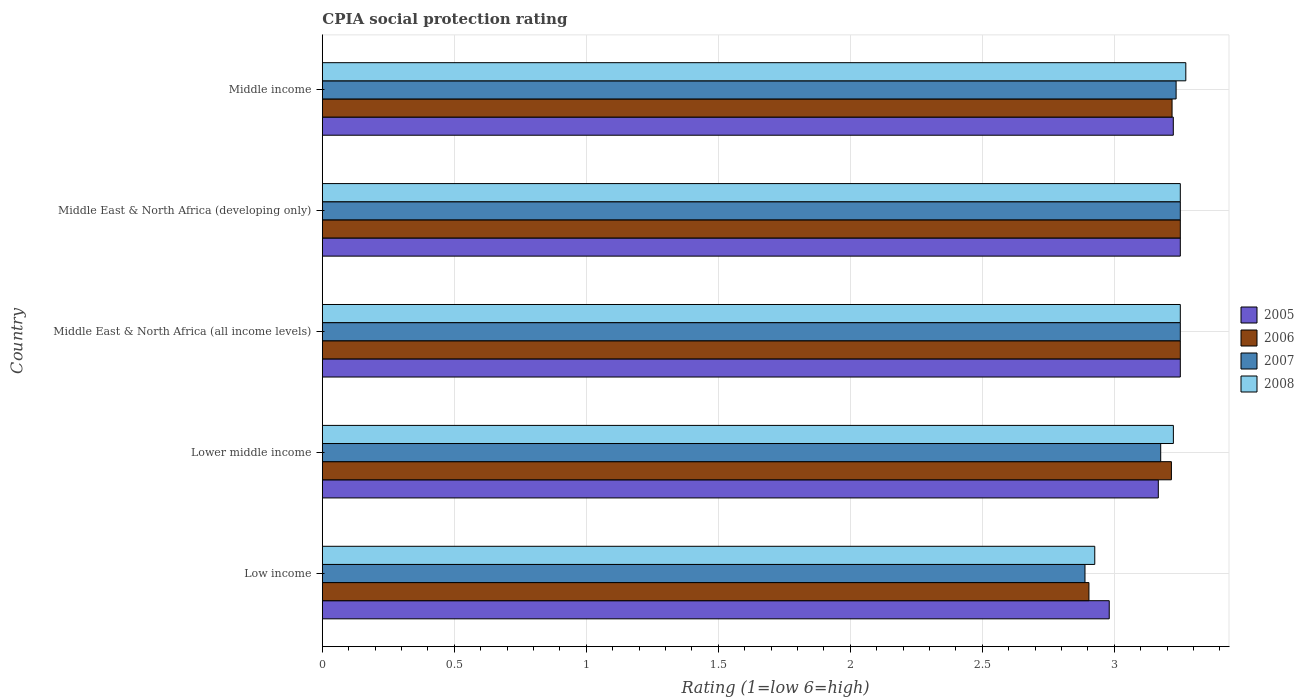How many groups of bars are there?
Your answer should be very brief. 5. Are the number of bars per tick equal to the number of legend labels?
Offer a terse response. Yes. What is the label of the 3rd group of bars from the top?
Your response must be concise. Middle East & North Africa (all income levels). In how many cases, is the number of bars for a given country not equal to the number of legend labels?
Provide a succinct answer. 0. What is the CPIA rating in 2008 in Middle income?
Provide a succinct answer. 3.27. Across all countries, what is the maximum CPIA rating in 2008?
Make the answer very short. 3.27. Across all countries, what is the minimum CPIA rating in 2008?
Your response must be concise. 2.93. In which country was the CPIA rating in 2006 maximum?
Your answer should be very brief. Middle East & North Africa (all income levels). In which country was the CPIA rating in 2006 minimum?
Ensure brevity in your answer.  Low income. What is the total CPIA rating in 2007 in the graph?
Your response must be concise. 15.8. What is the difference between the CPIA rating in 2008 in Low income and that in Middle East & North Africa (all income levels)?
Provide a succinct answer. -0.32. What is the difference between the CPIA rating in 2008 in Middle income and the CPIA rating in 2006 in Middle East & North Africa (developing only)?
Keep it short and to the point. 0.02. What is the average CPIA rating in 2005 per country?
Your response must be concise. 3.17. What is the ratio of the CPIA rating in 2008 in Low income to that in Lower middle income?
Your answer should be compact. 0.91. Is the difference between the CPIA rating in 2006 in Lower middle income and Middle income greater than the difference between the CPIA rating in 2007 in Lower middle income and Middle income?
Offer a very short reply. Yes. What is the difference between the highest and the second highest CPIA rating in 2007?
Keep it short and to the point. 0. What is the difference between the highest and the lowest CPIA rating in 2008?
Offer a terse response. 0.34. In how many countries, is the CPIA rating in 2005 greater than the average CPIA rating in 2005 taken over all countries?
Provide a short and direct response. 3. Is it the case that in every country, the sum of the CPIA rating in 2006 and CPIA rating in 2008 is greater than the sum of CPIA rating in 2007 and CPIA rating in 2005?
Your answer should be compact. No. What does the 4th bar from the top in Middle East & North Africa (all income levels) represents?
Offer a terse response. 2005. Are all the bars in the graph horizontal?
Ensure brevity in your answer.  Yes. How many countries are there in the graph?
Your answer should be very brief. 5. What is the difference between two consecutive major ticks on the X-axis?
Ensure brevity in your answer.  0.5. Does the graph contain any zero values?
Give a very brief answer. No. Does the graph contain grids?
Ensure brevity in your answer.  Yes. Where does the legend appear in the graph?
Your response must be concise. Center right. How many legend labels are there?
Keep it short and to the point. 4. What is the title of the graph?
Your answer should be compact. CPIA social protection rating. What is the label or title of the X-axis?
Provide a short and direct response. Rating (1=low 6=high). What is the label or title of the Y-axis?
Offer a terse response. Country. What is the Rating (1=low 6=high) of 2005 in Low income?
Make the answer very short. 2.98. What is the Rating (1=low 6=high) in 2006 in Low income?
Make the answer very short. 2.9. What is the Rating (1=low 6=high) in 2007 in Low income?
Your answer should be very brief. 2.89. What is the Rating (1=low 6=high) of 2008 in Low income?
Offer a very short reply. 2.93. What is the Rating (1=low 6=high) of 2005 in Lower middle income?
Your response must be concise. 3.17. What is the Rating (1=low 6=high) in 2006 in Lower middle income?
Provide a succinct answer. 3.22. What is the Rating (1=low 6=high) in 2007 in Lower middle income?
Offer a very short reply. 3.18. What is the Rating (1=low 6=high) in 2008 in Lower middle income?
Give a very brief answer. 3.22. What is the Rating (1=low 6=high) in 2005 in Middle East & North Africa (all income levels)?
Your answer should be compact. 3.25. What is the Rating (1=low 6=high) of 2007 in Middle East & North Africa (all income levels)?
Offer a very short reply. 3.25. What is the Rating (1=low 6=high) of 2007 in Middle East & North Africa (developing only)?
Your answer should be very brief. 3.25. What is the Rating (1=low 6=high) in 2008 in Middle East & North Africa (developing only)?
Give a very brief answer. 3.25. What is the Rating (1=low 6=high) in 2005 in Middle income?
Offer a terse response. 3.22. What is the Rating (1=low 6=high) of 2006 in Middle income?
Your response must be concise. 3.22. What is the Rating (1=low 6=high) of 2007 in Middle income?
Your response must be concise. 3.23. What is the Rating (1=low 6=high) of 2008 in Middle income?
Give a very brief answer. 3.27. Across all countries, what is the maximum Rating (1=low 6=high) of 2006?
Provide a short and direct response. 3.25. Across all countries, what is the maximum Rating (1=low 6=high) of 2007?
Provide a short and direct response. 3.25. Across all countries, what is the maximum Rating (1=low 6=high) in 2008?
Your response must be concise. 3.27. Across all countries, what is the minimum Rating (1=low 6=high) in 2005?
Your answer should be compact. 2.98. Across all countries, what is the minimum Rating (1=low 6=high) of 2006?
Your answer should be compact. 2.9. Across all countries, what is the minimum Rating (1=low 6=high) of 2007?
Ensure brevity in your answer.  2.89. Across all countries, what is the minimum Rating (1=low 6=high) of 2008?
Keep it short and to the point. 2.93. What is the total Rating (1=low 6=high) in 2005 in the graph?
Ensure brevity in your answer.  15.87. What is the total Rating (1=low 6=high) of 2006 in the graph?
Make the answer very short. 15.84. What is the total Rating (1=low 6=high) in 2007 in the graph?
Ensure brevity in your answer.  15.8. What is the total Rating (1=low 6=high) in 2008 in the graph?
Keep it short and to the point. 15.92. What is the difference between the Rating (1=low 6=high) of 2005 in Low income and that in Lower middle income?
Your answer should be very brief. -0.19. What is the difference between the Rating (1=low 6=high) in 2006 in Low income and that in Lower middle income?
Give a very brief answer. -0.31. What is the difference between the Rating (1=low 6=high) in 2007 in Low income and that in Lower middle income?
Provide a succinct answer. -0.29. What is the difference between the Rating (1=low 6=high) in 2008 in Low income and that in Lower middle income?
Your answer should be compact. -0.3. What is the difference between the Rating (1=low 6=high) of 2005 in Low income and that in Middle East & North Africa (all income levels)?
Your answer should be very brief. -0.27. What is the difference between the Rating (1=low 6=high) in 2006 in Low income and that in Middle East & North Africa (all income levels)?
Provide a short and direct response. -0.35. What is the difference between the Rating (1=low 6=high) in 2007 in Low income and that in Middle East & North Africa (all income levels)?
Offer a very short reply. -0.36. What is the difference between the Rating (1=low 6=high) of 2008 in Low income and that in Middle East & North Africa (all income levels)?
Offer a terse response. -0.32. What is the difference between the Rating (1=low 6=high) in 2005 in Low income and that in Middle East & North Africa (developing only)?
Offer a very short reply. -0.27. What is the difference between the Rating (1=low 6=high) in 2006 in Low income and that in Middle East & North Africa (developing only)?
Offer a terse response. -0.35. What is the difference between the Rating (1=low 6=high) in 2007 in Low income and that in Middle East & North Africa (developing only)?
Ensure brevity in your answer.  -0.36. What is the difference between the Rating (1=low 6=high) of 2008 in Low income and that in Middle East & North Africa (developing only)?
Offer a very short reply. -0.32. What is the difference between the Rating (1=low 6=high) of 2005 in Low income and that in Middle income?
Offer a very short reply. -0.24. What is the difference between the Rating (1=low 6=high) in 2006 in Low income and that in Middle income?
Your answer should be compact. -0.31. What is the difference between the Rating (1=low 6=high) of 2007 in Low income and that in Middle income?
Provide a succinct answer. -0.35. What is the difference between the Rating (1=low 6=high) of 2008 in Low income and that in Middle income?
Offer a terse response. -0.34. What is the difference between the Rating (1=low 6=high) of 2005 in Lower middle income and that in Middle East & North Africa (all income levels)?
Give a very brief answer. -0.08. What is the difference between the Rating (1=low 6=high) of 2006 in Lower middle income and that in Middle East & North Africa (all income levels)?
Ensure brevity in your answer.  -0.03. What is the difference between the Rating (1=low 6=high) in 2007 in Lower middle income and that in Middle East & North Africa (all income levels)?
Ensure brevity in your answer.  -0.07. What is the difference between the Rating (1=low 6=high) in 2008 in Lower middle income and that in Middle East & North Africa (all income levels)?
Offer a very short reply. -0.03. What is the difference between the Rating (1=low 6=high) of 2005 in Lower middle income and that in Middle East & North Africa (developing only)?
Give a very brief answer. -0.08. What is the difference between the Rating (1=low 6=high) of 2006 in Lower middle income and that in Middle East & North Africa (developing only)?
Keep it short and to the point. -0.03. What is the difference between the Rating (1=low 6=high) in 2007 in Lower middle income and that in Middle East & North Africa (developing only)?
Provide a short and direct response. -0.07. What is the difference between the Rating (1=low 6=high) of 2008 in Lower middle income and that in Middle East & North Africa (developing only)?
Your response must be concise. -0.03. What is the difference between the Rating (1=low 6=high) of 2005 in Lower middle income and that in Middle income?
Provide a succinct answer. -0.06. What is the difference between the Rating (1=low 6=high) of 2006 in Lower middle income and that in Middle income?
Offer a terse response. -0. What is the difference between the Rating (1=low 6=high) in 2007 in Lower middle income and that in Middle income?
Provide a short and direct response. -0.06. What is the difference between the Rating (1=low 6=high) in 2008 in Lower middle income and that in Middle income?
Provide a succinct answer. -0.05. What is the difference between the Rating (1=low 6=high) of 2007 in Middle East & North Africa (all income levels) and that in Middle East & North Africa (developing only)?
Provide a short and direct response. 0. What is the difference between the Rating (1=low 6=high) of 2005 in Middle East & North Africa (all income levels) and that in Middle income?
Keep it short and to the point. 0.03. What is the difference between the Rating (1=low 6=high) in 2006 in Middle East & North Africa (all income levels) and that in Middle income?
Offer a very short reply. 0.03. What is the difference between the Rating (1=low 6=high) in 2007 in Middle East & North Africa (all income levels) and that in Middle income?
Your answer should be compact. 0.02. What is the difference between the Rating (1=low 6=high) of 2008 in Middle East & North Africa (all income levels) and that in Middle income?
Keep it short and to the point. -0.02. What is the difference between the Rating (1=low 6=high) of 2005 in Middle East & North Africa (developing only) and that in Middle income?
Keep it short and to the point. 0.03. What is the difference between the Rating (1=low 6=high) in 2006 in Middle East & North Africa (developing only) and that in Middle income?
Offer a terse response. 0.03. What is the difference between the Rating (1=low 6=high) in 2007 in Middle East & North Africa (developing only) and that in Middle income?
Provide a succinct answer. 0.02. What is the difference between the Rating (1=low 6=high) of 2008 in Middle East & North Africa (developing only) and that in Middle income?
Keep it short and to the point. -0.02. What is the difference between the Rating (1=low 6=high) in 2005 in Low income and the Rating (1=low 6=high) in 2006 in Lower middle income?
Your response must be concise. -0.24. What is the difference between the Rating (1=low 6=high) in 2005 in Low income and the Rating (1=low 6=high) in 2007 in Lower middle income?
Provide a succinct answer. -0.19. What is the difference between the Rating (1=low 6=high) of 2005 in Low income and the Rating (1=low 6=high) of 2008 in Lower middle income?
Keep it short and to the point. -0.24. What is the difference between the Rating (1=low 6=high) of 2006 in Low income and the Rating (1=low 6=high) of 2007 in Lower middle income?
Ensure brevity in your answer.  -0.27. What is the difference between the Rating (1=low 6=high) in 2006 in Low income and the Rating (1=low 6=high) in 2008 in Lower middle income?
Provide a short and direct response. -0.32. What is the difference between the Rating (1=low 6=high) in 2007 in Low income and the Rating (1=low 6=high) in 2008 in Lower middle income?
Your answer should be very brief. -0.33. What is the difference between the Rating (1=low 6=high) of 2005 in Low income and the Rating (1=low 6=high) of 2006 in Middle East & North Africa (all income levels)?
Make the answer very short. -0.27. What is the difference between the Rating (1=low 6=high) of 2005 in Low income and the Rating (1=low 6=high) of 2007 in Middle East & North Africa (all income levels)?
Ensure brevity in your answer.  -0.27. What is the difference between the Rating (1=low 6=high) in 2005 in Low income and the Rating (1=low 6=high) in 2008 in Middle East & North Africa (all income levels)?
Keep it short and to the point. -0.27. What is the difference between the Rating (1=low 6=high) in 2006 in Low income and the Rating (1=low 6=high) in 2007 in Middle East & North Africa (all income levels)?
Offer a terse response. -0.35. What is the difference between the Rating (1=low 6=high) of 2006 in Low income and the Rating (1=low 6=high) of 2008 in Middle East & North Africa (all income levels)?
Your answer should be very brief. -0.35. What is the difference between the Rating (1=low 6=high) of 2007 in Low income and the Rating (1=low 6=high) of 2008 in Middle East & North Africa (all income levels)?
Keep it short and to the point. -0.36. What is the difference between the Rating (1=low 6=high) of 2005 in Low income and the Rating (1=low 6=high) of 2006 in Middle East & North Africa (developing only)?
Your answer should be compact. -0.27. What is the difference between the Rating (1=low 6=high) in 2005 in Low income and the Rating (1=low 6=high) in 2007 in Middle East & North Africa (developing only)?
Provide a short and direct response. -0.27. What is the difference between the Rating (1=low 6=high) in 2005 in Low income and the Rating (1=low 6=high) in 2008 in Middle East & North Africa (developing only)?
Keep it short and to the point. -0.27. What is the difference between the Rating (1=low 6=high) in 2006 in Low income and the Rating (1=low 6=high) in 2007 in Middle East & North Africa (developing only)?
Provide a succinct answer. -0.35. What is the difference between the Rating (1=low 6=high) of 2006 in Low income and the Rating (1=low 6=high) of 2008 in Middle East & North Africa (developing only)?
Provide a succinct answer. -0.35. What is the difference between the Rating (1=low 6=high) of 2007 in Low income and the Rating (1=low 6=high) of 2008 in Middle East & North Africa (developing only)?
Your answer should be very brief. -0.36. What is the difference between the Rating (1=low 6=high) in 2005 in Low income and the Rating (1=low 6=high) in 2006 in Middle income?
Provide a short and direct response. -0.24. What is the difference between the Rating (1=low 6=high) in 2005 in Low income and the Rating (1=low 6=high) in 2007 in Middle income?
Keep it short and to the point. -0.25. What is the difference between the Rating (1=low 6=high) in 2005 in Low income and the Rating (1=low 6=high) in 2008 in Middle income?
Provide a short and direct response. -0.29. What is the difference between the Rating (1=low 6=high) in 2006 in Low income and the Rating (1=low 6=high) in 2007 in Middle income?
Offer a terse response. -0.33. What is the difference between the Rating (1=low 6=high) of 2006 in Low income and the Rating (1=low 6=high) of 2008 in Middle income?
Give a very brief answer. -0.37. What is the difference between the Rating (1=low 6=high) in 2007 in Low income and the Rating (1=low 6=high) in 2008 in Middle income?
Keep it short and to the point. -0.38. What is the difference between the Rating (1=low 6=high) in 2005 in Lower middle income and the Rating (1=low 6=high) in 2006 in Middle East & North Africa (all income levels)?
Offer a terse response. -0.08. What is the difference between the Rating (1=low 6=high) in 2005 in Lower middle income and the Rating (1=low 6=high) in 2007 in Middle East & North Africa (all income levels)?
Your answer should be very brief. -0.08. What is the difference between the Rating (1=low 6=high) in 2005 in Lower middle income and the Rating (1=low 6=high) in 2008 in Middle East & North Africa (all income levels)?
Make the answer very short. -0.08. What is the difference between the Rating (1=low 6=high) of 2006 in Lower middle income and the Rating (1=low 6=high) of 2007 in Middle East & North Africa (all income levels)?
Make the answer very short. -0.03. What is the difference between the Rating (1=low 6=high) in 2006 in Lower middle income and the Rating (1=low 6=high) in 2008 in Middle East & North Africa (all income levels)?
Your answer should be very brief. -0.03. What is the difference between the Rating (1=low 6=high) of 2007 in Lower middle income and the Rating (1=low 6=high) of 2008 in Middle East & North Africa (all income levels)?
Provide a succinct answer. -0.07. What is the difference between the Rating (1=low 6=high) in 2005 in Lower middle income and the Rating (1=low 6=high) in 2006 in Middle East & North Africa (developing only)?
Your answer should be compact. -0.08. What is the difference between the Rating (1=low 6=high) of 2005 in Lower middle income and the Rating (1=low 6=high) of 2007 in Middle East & North Africa (developing only)?
Give a very brief answer. -0.08. What is the difference between the Rating (1=low 6=high) of 2005 in Lower middle income and the Rating (1=low 6=high) of 2008 in Middle East & North Africa (developing only)?
Keep it short and to the point. -0.08. What is the difference between the Rating (1=low 6=high) of 2006 in Lower middle income and the Rating (1=low 6=high) of 2007 in Middle East & North Africa (developing only)?
Your response must be concise. -0.03. What is the difference between the Rating (1=low 6=high) in 2006 in Lower middle income and the Rating (1=low 6=high) in 2008 in Middle East & North Africa (developing only)?
Keep it short and to the point. -0.03. What is the difference between the Rating (1=low 6=high) in 2007 in Lower middle income and the Rating (1=low 6=high) in 2008 in Middle East & North Africa (developing only)?
Your answer should be compact. -0.07. What is the difference between the Rating (1=low 6=high) in 2005 in Lower middle income and the Rating (1=low 6=high) in 2006 in Middle income?
Offer a very short reply. -0.05. What is the difference between the Rating (1=low 6=high) of 2005 in Lower middle income and the Rating (1=low 6=high) of 2007 in Middle income?
Your response must be concise. -0.07. What is the difference between the Rating (1=low 6=high) of 2005 in Lower middle income and the Rating (1=low 6=high) of 2008 in Middle income?
Your response must be concise. -0.1. What is the difference between the Rating (1=low 6=high) of 2006 in Lower middle income and the Rating (1=low 6=high) of 2007 in Middle income?
Your answer should be very brief. -0.02. What is the difference between the Rating (1=low 6=high) in 2006 in Lower middle income and the Rating (1=low 6=high) in 2008 in Middle income?
Make the answer very short. -0.05. What is the difference between the Rating (1=low 6=high) in 2007 in Lower middle income and the Rating (1=low 6=high) in 2008 in Middle income?
Provide a short and direct response. -0.1. What is the difference between the Rating (1=low 6=high) of 2005 in Middle East & North Africa (all income levels) and the Rating (1=low 6=high) of 2006 in Middle East & North Africa (developing only)?
Your response must be concise. 0. What is the difference between the Rating (1=low 6=high) in 2005 in Middle East & North Africa (all income levels) and the Rating (1=low 6=high) in 2007 in Middle East & North Africa (developing only)?
Keep it short and to the point. 0. What is the difference between the Rating (1=low 6=high) in 2006 in Middle East & North Africa (all income levels) and the Rating (1=low 6=high) in 2007 in Middle East & North Africa (developing only)?
Your response must be concise. 0. What is the difference between the Rating (1=low 6=high) in 2006 in Middle East & North Africa (all income levels) and the Rating (1=low 6=high) in 2008 in Middle East & North Africa (developing only)?
Ensure brevity in your answer.  0. What is the difference between the Rating (1=low 6=high) of 2007 in Middle East & North Africa (all income levels) and the Rating (1=low 6=high) of 2008 in Middle East & North Africa (developing only)?
Keep it short and to the point. 0. What is the difference between the Rating (1=low 6=high) of 2005 in Middle East & North Africa (all income levels) and the Rating (1=low 6=high) of 2006 in Middle income?
Give a very brief answer. 0.03. What is the difference between the Rating (1=low 6=high) of 2005 in Middle East & North Africa (all income levels) and the Rating (1=low 6=high) of 2007 in Middle income?
Offer a terse response. 0.02. What is the difference between the Rating (1=low 6=high) in 2005 in Middle East & North Africa (all income levels) and the Rating (1=low 6=high) in 2008 in Middle income?
Keep it short and to the point. -0.02. What is the difference between the Rating (1=low 6=high) in 2006 in Middle East & North Africa (all income levels) and the Rating (1=low 6=high) in 2007 in Middle income?
Keep it short and to the point. 0.02. What is the difference between the Rating (1=low 6=high) of 2006 in Middle East & North Africa (all income levels) and the Rating (1=low 6=high) of 2008 in Middle income?
Your answer should be very brief. -0.02. What is the difference between the Rating (1=low 6=high) in 2007 in Middle East & North Africa (all income levels) and the Rating (1=low 6=high) in 2008 in Middle income?
Offer a very short reply. -0.02. What is the difference between the Rating (1=low 6=high) in 2005 in Middle East & North Africa (developing only) and the Rating (1=low 6=high) in 2006 in Middle income?
Ensure brevity in your answer.  0.03. What is the difference between the Rating (1=low 6=high) in 2005 in Middle East & North Africa (developing only) and the Rating (1=low 6=high) in 2007 in Middle income?
Your answer should be very brief. 0.02. What is the difference between the Rating (1=low 6=high) in 2005 in Middle East & North Africa (developing only) and the Rating (1=low 6=high) in 2008 in Middle income?
Keep it short and to the point. -0.02. What is the difference between the Rating (1=low 6=high) in 2006 in Middle East & North Africa (developing only) and the Rating (1=low 6=high) in 2007 in Middle income?
Your answer should be compact. 0.02. What is the difference between the Rating (1=low 6=high) in 2006 in Middle East & North Africa (developing only) and the Rating (1=low 6=high) in 2008 in Middle income?
Ensure brevity in your answer.  -0.02. What is the difference between the Rating (1=low 6=high) in 2007 in Middle East & North Africa (developing only) and the Rating (1=low 6=high) in 2008 in Middle income?
Provide a short and direct response. -0.02. What is the average Rating (1=low 6=high) of 2005 per country?
Your answer should be very brief. 3.17. What is the average Rating (1=low 6=high) of 2006 per country?
Your response must be concise. 3.17. What is the average Rating (1=low 6=high) of 2007 per country?
Give a very brief answer. 3.16. What is the average Rating (1=low 6=high) of 2008 per country?
Keep it short and to the point. 3.18. What is the difference between the Rating (1=low 6=high) of 2005 and Rating (1=low 6=high) of 2006 in Low income?
Keep it short and to the point. 0.08. What is the difference between the Rating (1=low 6=high) of 2005 and Rating (1=low 6=high) of 2007 in Low income?
Provide a succinct answer. 0.09. What is the difference between the Rating (1=low 6=high) in 2005 and Rating (1=low 6=high) in 2008 in Low income?
Provide a short and direct response. 0.05. What is the difference between the Rating (1=low 6=high) of 2006 and Rating (1=low 6=high) of 2007 in Low income?
Provide a short and direct response. 0.01. What is the difference between the Rating (1=low 6=high) of 2006 and Rating (1=low 6=high) of 2008 in Low income?
Give a very brief answer. -0.02. What is the difference between the Rating (1=low 6=high) in 2007 and Rating (1=low 6=high) in 2008 in Low income?
Your answer should be very brief. -0.04. What is the difference between the Rating (1=low 6=high) of 2005 and Rating (1=low 6=high) of 2006 in Lower middle income?
Make the answer very short. -0.05. What is the difference between the Rating (1=low 6=high) of 2005 and Rating (1=low 6=high) of 2007 in Lower middle income?
Offer a very short reply. -0.01. What is the difference between the Rating (1=low 6=high) in 2005 and Rating (1=low 6=high) in 2008 in Lower middle income?
Make the answer very short. -0.06. What is the difference between the Rating (1=low 6=high) in 2006 and Rating (1=low 6=high) in 2007 in Lower middle income?
Your answer should be compact. 0.04. What is the difference between the Rating (1=low 6=high) of 2006 and Rating (1=low 6=high) of 2008 in Lower middle income?
Provide a short and direct response. -0.01. What is the difference between the Rating (1=low 6=high) of 2007 and Rating (1=low 6=high) of 2008 in Lower middle income?
Keep it short and to the point. -0.05. What is the difference between the Rating (1=low 6=high) of 2005 and Rating (1=low 6=high) of 2006 in Middle East & North Africa (all income levels)?
Keep it short and to the point. 0. What is the difference between the Rating (1=low 6=high) of 2005 and Rating (1=low 6=high) of 2007 in Middle East & North Africa (all income levels)?
Give a very brief answer. 0. What is the difference between the Rating (1=low 6=high) of 2005 and Rating (1=low 6=high) of 2006 in Middle East & North Africa (developing only)?
Offer a terse response. 0. What is the difference between the Rating (1=low 6=high) in 2006 and Rating (1=low 6=high) in 2007 in Middle East & North Africa (developing only)?
Your answer should be compact. 0. What is the difference between the Rating (1=low 6=high) of 2006 and Rating (1=low 6=high) of 2008 in Middle East & North Africa (developing only)?
Offer a very short reply. 0. What is the difference between the Rating (1=low 6=high) of 2007 and Rating (1=low 6=high) of 2008 in Middle East & North Africa (developing only)?
Make the answer very short. 0. What is the difference between the Rating (1=low 6=high) in 2005 and Rating (1=low 6=high) in 2006 in Middle income?
Offer a very short reply. 0. What is the difference between the Rating (1=low 6=high) of 2005 and Rating (1=low 6=high) of 2007 in Middle income?
Provide a short and direct response. -0.01. What is the difference between the Rating (1=low 6=high) of 2005 and Rating (1=low 6=high) of 2008 in Middle income?
Provide a succinct answer. -0.05. What is the difference between the Rating (1=low 6=high) of 2006 and Rating (1=low 6=high) of 2007 in Middle income?
Offer a terse response. -0.02. What is the difference between the Rating (1=low 6=high) in 2006 and Rating (1=low 6=high) in 2008 in Middle income?
Provide a short and direct response. -0.05. What is the difference between the Rating (1=low 6=high) of 2007 and Rating (1=low 6=high) of 2008 in Middle income?
Keep it short and to the point. -0.04. What is the ratio of the Rating (1=low 6=high) of 2005 in Low income to that in Lower middle income?
Ensure brevity in your answer.  0.94. What is the ratio of the Rating (1=low 6=high) in 2006 in Low income to that in Lower middle income?
Your response must be concise. 0.9. What is the ratio of the Rating (1=low 6=high) in 2007 in Low income to that in Lower middle income?
Your answer should be compact. 0.91. What is the ratio of the Rating (1=low 6=high) of 2008 in Low income to that in Lower middle income?
Make the answer very short. 0.91. What is the ratio of the Rating (1=low 6=high) of 2005 in Low income to that in Middle East & North Africa (all income levels)?
Offer a terse response. 0.92. What is the ratio of the Rating (1=low 6=high) of 2006 in Low income to that in Middle East & North Africa (all income levels)?
Keep it short and to the point. 0.89. What is the ratio of the Rating (1=low 6=high) of 2007 in Low income to that in Middle East & North Africa (all income levels)?
Keep it short and to the point. 0.89. What is the ratio of the Rating (1=low 6=high) of 2008 in Low income to that in Middle East & North Africa (all income levels)?
Make the answer very short. 0.9. What is the ratio of the Rating (1=low 6=high) of 2005 in Low income to that in Middle East & North Africa (developing only)?
Offer a terse response. 0.92. What is the ratio of the Rating (1=low 6=high) in 2006 in Low income to that in Middle East & North Africa (developing only)?
Give a very brief answer. 0.89. What is the ratio of the Rating (1=low 6=high) in 2008 in Low income to that in Middle East & North Africa (developing only)?
Offer a terse response. 0.9. What is the ratio of the Rating (1=low 6=high) in 2005 in Low income to that in Middle income?
Your answer should be compact. 0.92. What is the ratio of the Rating (1=low 6=high) of 2006 in Low income to that in Middle income?
Keep it short and to the point. 0.9. What is the ratio of the Rating (1=low 6=high) in 2007 in Low income to that in Middle income?
Your answer should be very brief. 0.89. What is the ratio of the Rating (1=low 6=high) in 2008 in Low income to that in Middle income?
Offer a terse response. 0.89. What is the ratio of the Rating (1=low 6=high) of 2005 in Lower middle income to that in Middle East & North Africa (all income levels)?
Provide a succinct answer. 0.97. What is the ratio of the Rating (1=low 6=high) in 2007 in Lower middle income to that in Middle East & North Africa (all income levels)?
Offer a terse response. 0.98. What is the ratio of the Rating (1=low 6=high) in 2005 in Lower middle income to that in Middle East & North Africa (developing only)?
Give a very brief answer. 0.97. What is the ratio of the Rating (1=low 6=high) of 2006 in Lower middle income to that in Middle East & North Africa (developing only)?
Your answer should be very brief. 0.99. What is the ratio of the Rating (1=low 6=high) of 2007 in Lower middle income to that in Middle East & North Africa (developing only)?
Keep it short and to the point. 0.98. What is the ratio of the Rating (1=low 6=high) in 2008 in Lower middle income to that in Middle East & North Africa (developing only)?
Keep it short and to the point. 0.99. What is the ratio of the Rating (1=low 6=high) in 2005 in Lower middle income to that in Middle income?
Ensure brevity in your answer.  0.98. What is the ratio of the Rating (1=low 6=high) of 2006 in Lower middle income to that in Middle income?
Offer a terse response. 1. What is the ratio of the Rating (1=low 6=high) in 2007 in Lower middle income to that in Middle income?
Offer a terse response. 0.98. What is the ratio of the Rating (1=low 6=high) in 2008 in Lower middle income to that in Middle income?
Provide a succinct answer. 0.99. What is the ratio of the Rating (1=low 6=high) of 2005 in Middle East & North Africa (all income levels) to that in Middle East & North Africa (developing only)?
Make the answer very short. 1. What is the ratio of the Rating (1=low 6=high) in 2006 in Middle East & North Africa (all income levels) to that in Middle East & North Africa (developing only)?
Ensure brevity in your answer.  1. What is the ratio of the Rating (1=low 6=high) in 2007 in Middle East & North Africa (all income levels) to that in Middle East & North Africa (developing only)?
Your answer should be very brief. 1. What is the ratio of the Rating (1=low 6=high) of 2008 in Middle East & North Africa (all income levels) to that in Middle East & North Africa (developing only)?
Make the answer very short. 1. What is the ratio of the Rating (1=low 6=high) in 2005 in Middle East & North Africa (all income levels) to that in Middle income?
Make the answer very short. 1.01. What is the ratio of the Rating (1=low 6=high) of 2006 in Middle East & North Africa (all income levels) to that in Middle income?
Provide a short and direct response. 1.01. What is the ratio of the Rating (1=low 6=high) in 2007 in Middle East & North Africa (all income levels) to that in Middle income?
Keep it short and to the point. 1. What is the ratio of the Rating (1=low 6=high) in 2008 in Middle East & North Africa (all income levels) to that in Middle income?
Provide a succinct answer. 0.99. What is the ratio of the Rating (1=low 6=high) of 2005 in Middle East & North Africa (developing only) to that in Middle income?
Provide a short and direct response. 1.01. What is the ratio of the Rating (1=low 6=high) of 2006 in Middle East & North Africa (developing only) to that in Middle income?
Offer a very short reply. 1.01. What is the difference between the highest and the second highest Rating (1=low 6=high) in 2005?
Give a very brief answer. 0. What is the difference between the highest and the second highest Rating (1=low 6=high) of 2007?
Provide a succinct answer. 0. What is the difference between the highest and the second highest Rating (1=low 6=high) in 2008?
Offer a terse response. 0.02. What is the difference between the highest and the lowest Rating (1=low 6=high) of 2005?
Keep it short and to the point. 0.27. What is the difference between the highest and the lowest Rating (1=low 6=high) in 2006?
Offer a terse response. 0.35. What is the difference between the highest and the lowest Rating (1=low 6=high) of 2007?
Give a very brief answer. 0.36. What is the difference between the highest and the lowest Rating (1=low 6=high) of 2008?
Offer a terse response. 0.34. 